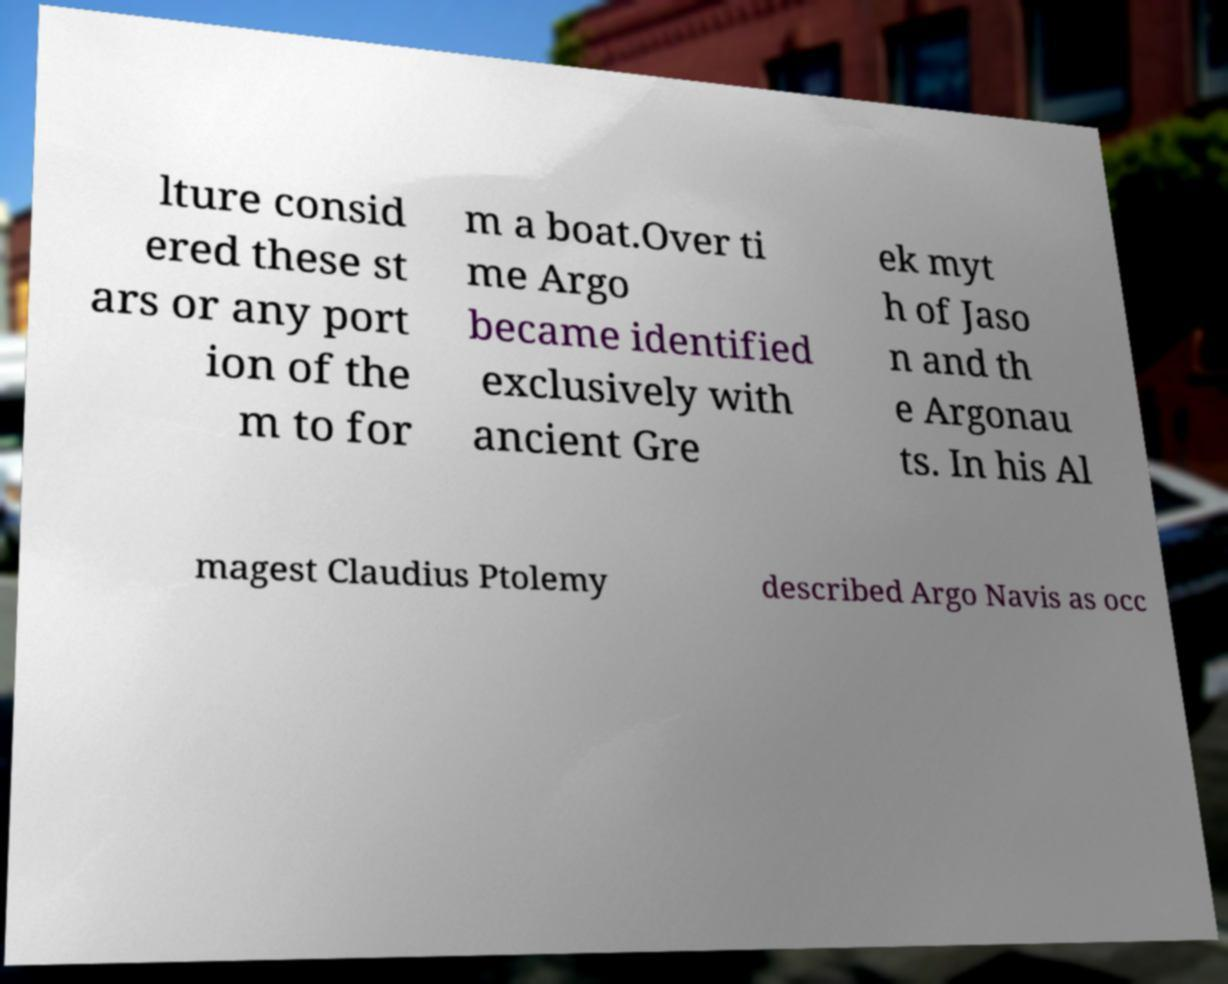For documentation purposes, I need the text within this image transcribed. Could you provide that? lture consid ered these st ars or any port ion of the m to for m a boat.Over ti me Argo became identified exclusively with ancient Gre ek myt h of Jaso n and th e Argonau ts. In his Al magest Claudius Ptolemy described Argo Navis as occ 